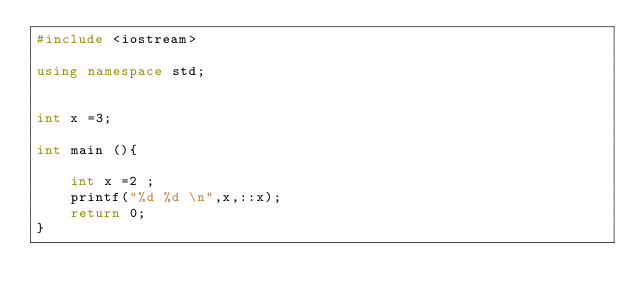Convert code to text. <code><loc_0><loc_0><loc_500><loc_500><_C++_>#include <iostream>

using namespace std;


int x =3;

int main (){

    int x =2 ;
    printf("%d %d \n",x,::x);
    return 0;
} </code> 